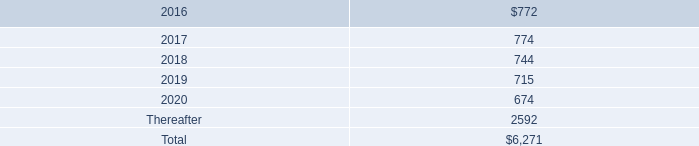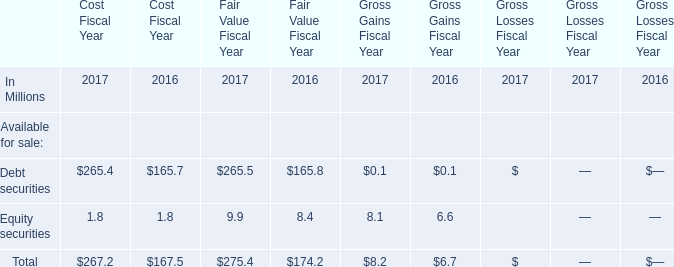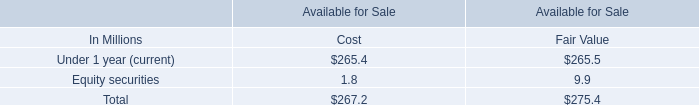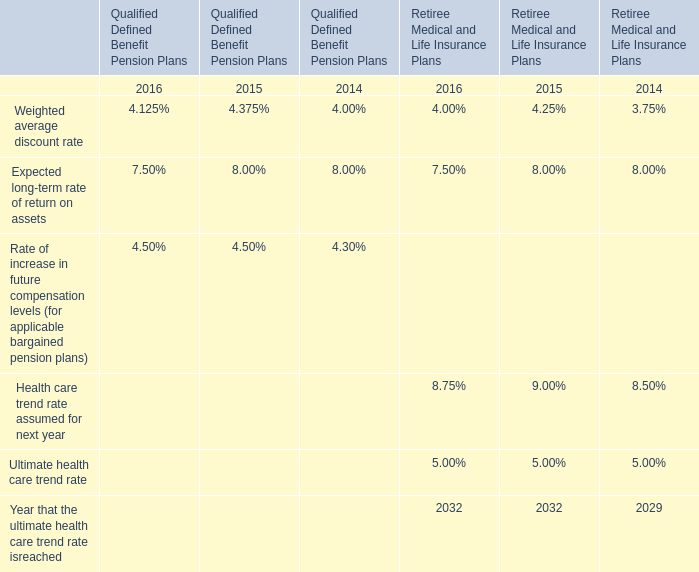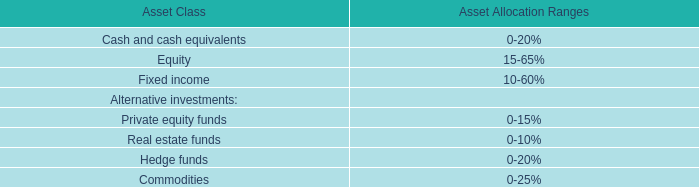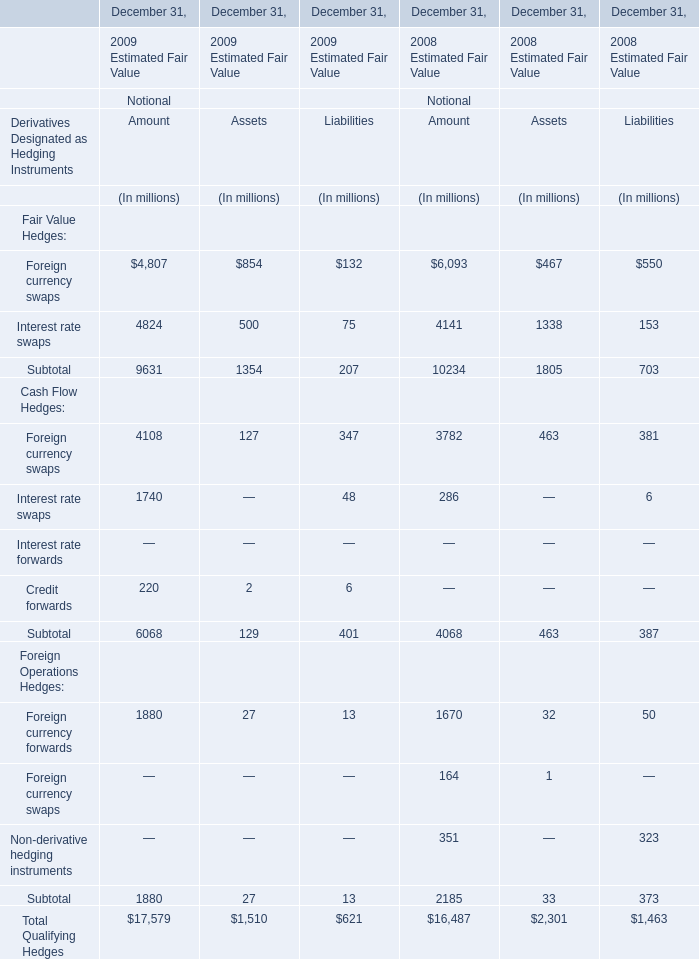How many years does Interest rate swaps stay higher than Interest rate forwards for Liabilities? 
Answer: 2. 